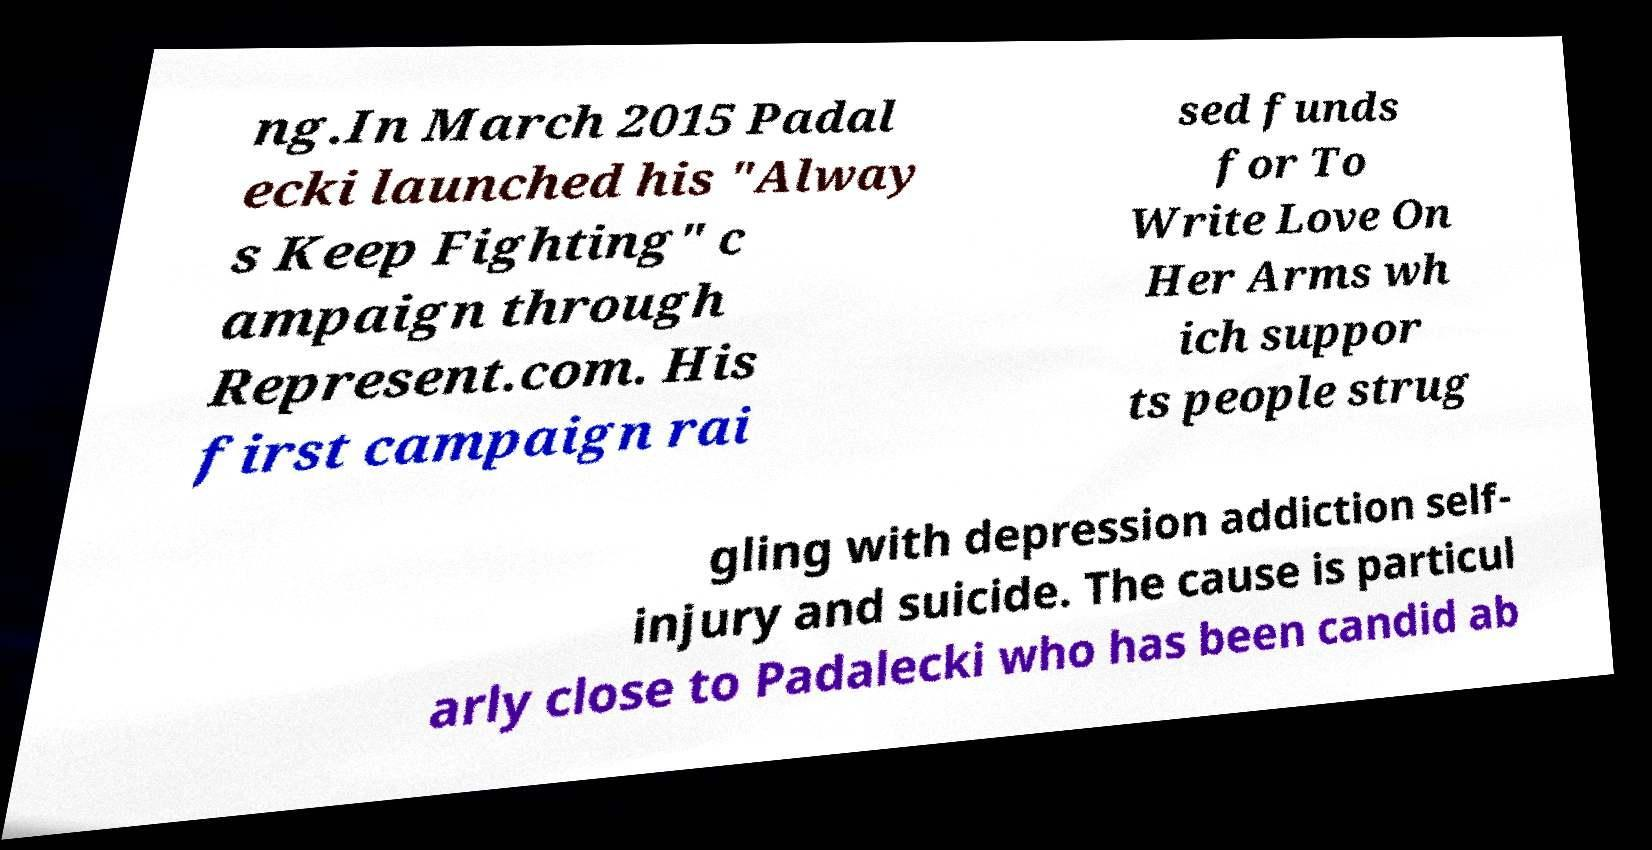Please read and relay the text visible in this image. What does it say? ng.In March 2015 Padal ecki launched his "Alway s Keep Fighting" c ampaign through Represent.com. His first campaign rai sed funds for To Write Love On Her Arms wh ich suppor ts people strug gling with depression addiction self- injury and suicide. The cause is particul arly close to Padalecki who has been candid ab 